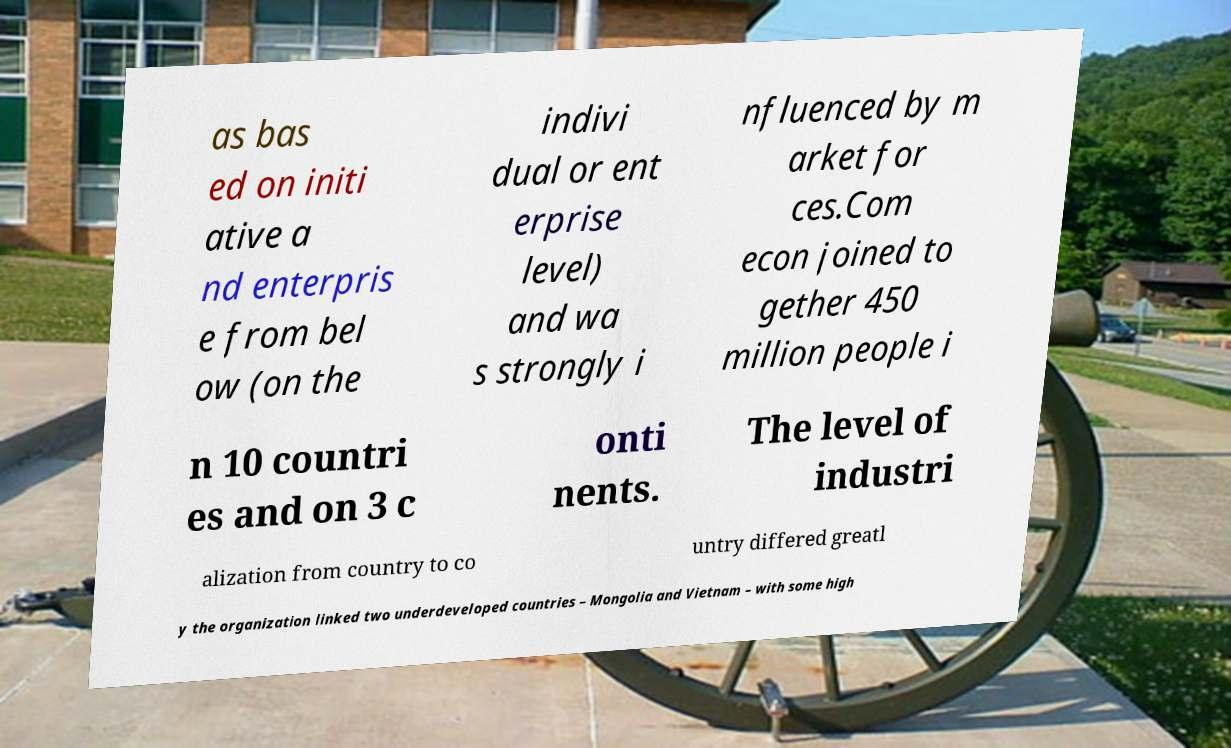Could you extract and type out the text from this image? as bas ed on initi ative a nd enterpris e from bel ow (on the indivi dual or ent erprise level) and wa s strongly i nfluenced by m arket for ces.Com econ joined to gether 450 million people i n 10 countri es and on 3 c onti nents. The level of industri alization from country to co untry differed greatl y the organization linked two underdeveloped countries – Mongolia and Vietnam – with some high 